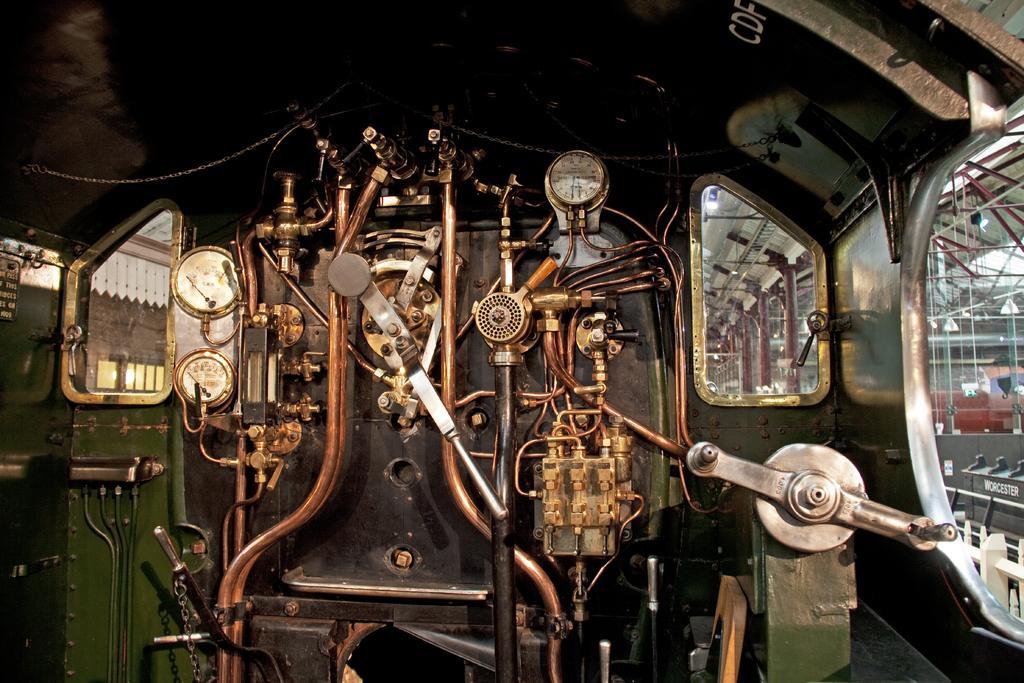Please provide a concise description of this image. In this picture we can observe a machine. This is looking like an engine of a locomotive. In the background we can observe red color pillars. 